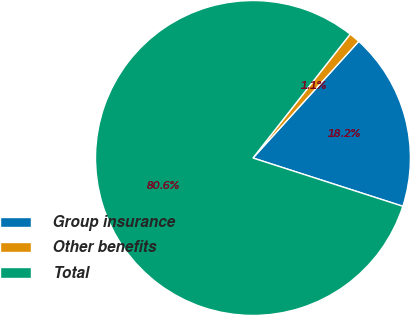Convert chart to OTSL. <chart><loc_0><loc_0><loc_500><loc_500><pie_chart><fcel>Group insurance<fcel>Other benefits<fcel>Total<nl><fcel>18.24%<fcel>1.13%<fcel>80.63%<nl></chart> 